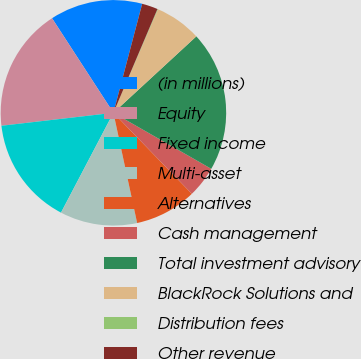<chart> <loc_0><loc_0><loc_500><loc_500><pie_chart><fcel>(in millions)<fcel>Equity<fcel>Fixed income<fcel>Multi-asset<fcel>Alternatives<fcel>Cash management<fcel>Total investment advisory<fcel>BlackRock Solutions and<fcel>Distribution fees<fcel>Other revenue<nl><fcel>13.27%<fcel>17.67%<fcel>15.47%<fcel>11.07%<fcel>8.87%<fcel>4.48%<fcel>20.13%<fcel>6.68%<fcel>0.08%<fcel>2.28%<nl></chart> 